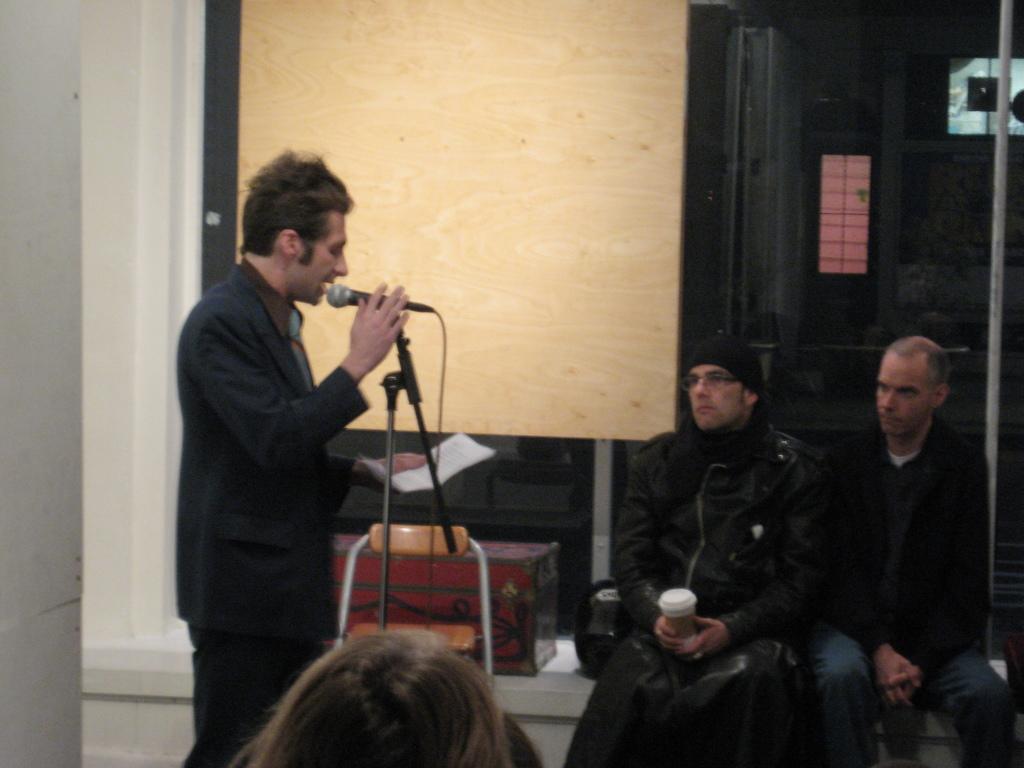Describe this image in one or two sentences. In this picture there is a man standing and holding a microphone in his right hand and a paper in his left hand. There are other two men sitting to the right corner of the image. In the background there is a chair, a box and wall. 